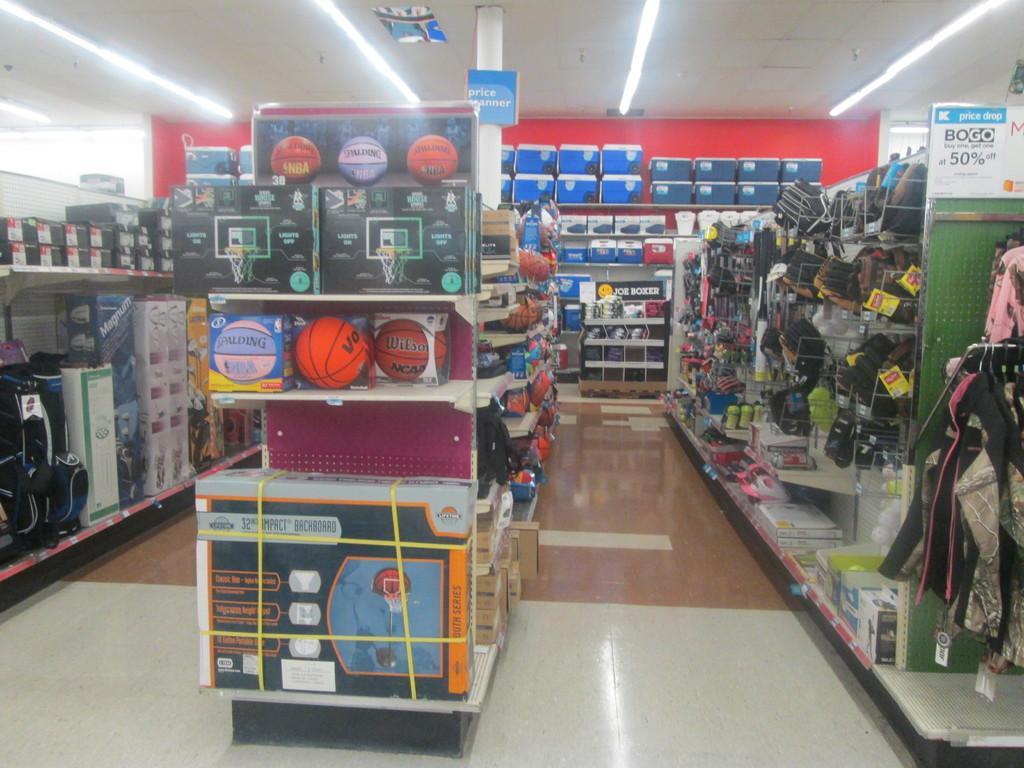Please provide a concise description of this image. In this image, we can see the interior view of a shop. We can see the ground. We can see some racks with objects like balls, clothes. We can also see some boards with text written. We can also shelves with some objects that are attached to the wall. We can see some lights. We can see the roof. We can see a pillar. 